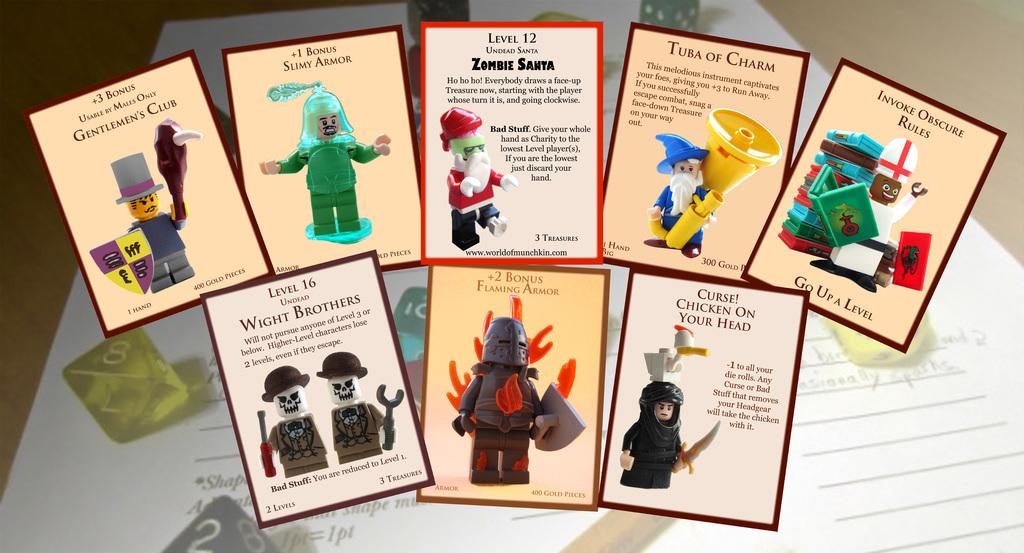<image>
Describe the image concisely. a collection of cards with the first one saying +3 bonus 